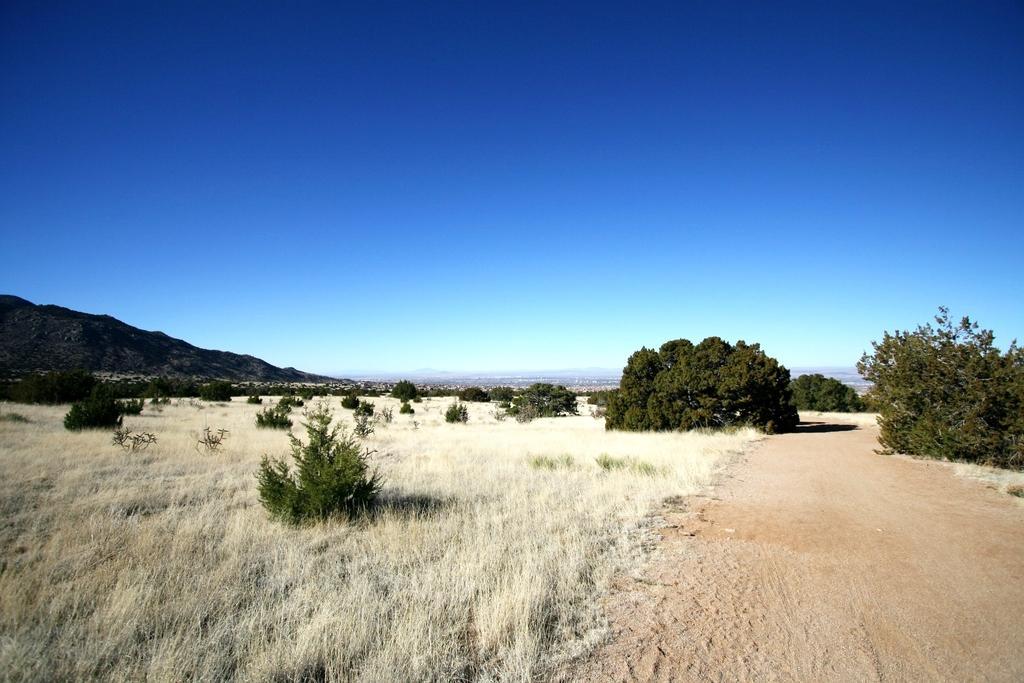In one or two sentences, can you explain what this image depicts? In this image I can see the ground, some grass and few plants which are green in color. In the background I can see few mountains and the sky. 